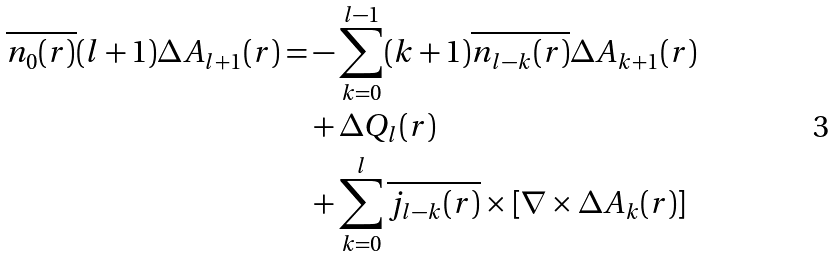<formula> <loc_0><loc_0><loc_500><loc_500>\overline { n _ { 0 } ( { r } ) } ( l + 1 ) \Delta A _ { l + 1 } ( { r } ) = & - \sum _ { k = 0 } ^ { l - 1 } ( k + 1 ) \overline { n _ { l - k } ( { r } ) } \Delta A _ { k + 1 } ( { r } ) \\ & + \Delta Q _ { l } ( { r } ) \\ & + \sum _ { k = 0 } ^ { l } \overline { j _ { l - k } ( { r } ) } \times \left [ \nabla \times \Delta A _ { k } ( { r } ) \right ]</formula> 